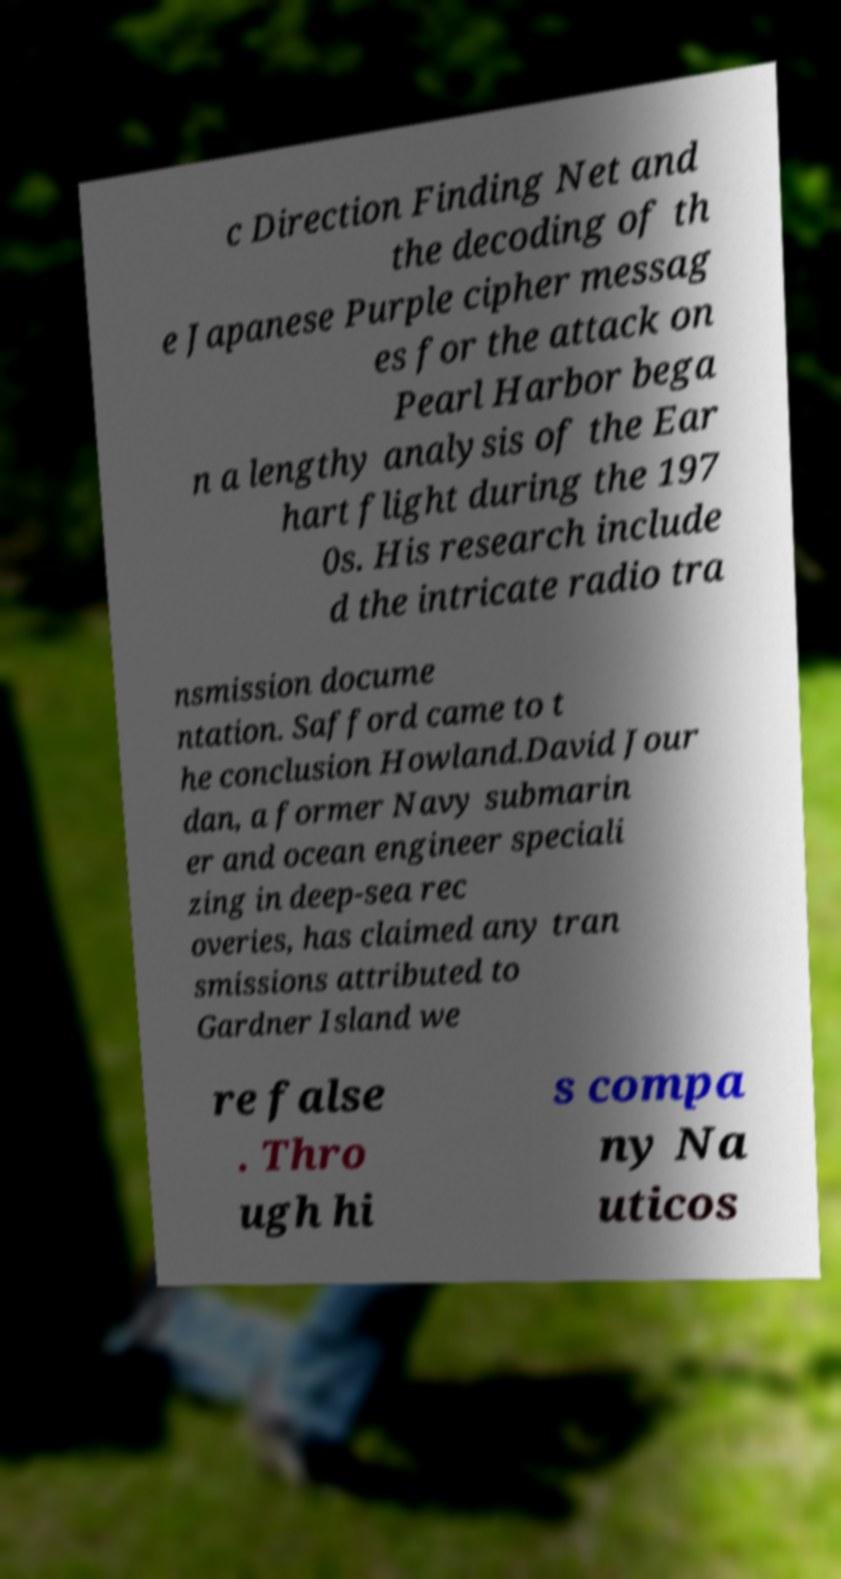Please read and relay the text visible in this image. What does it say? c Direction Finding Net and the decoding of th e Japanese Purple cipher messag es for the attack on Pearl Harbor bega n a lengthy analysis of the Ear hart flight during the 197 0s. His research include d the intricate radio tra nsmission docume ntation. Safford came to t he conclusion Howland.David Jour dan, a former Navy submarin er and ocean engineer speciali zing in deep-sea rec overies, has claimed any tran smissions attributed to Gardner Island we re false . Thro ugh hi s compa ny Na uticos 